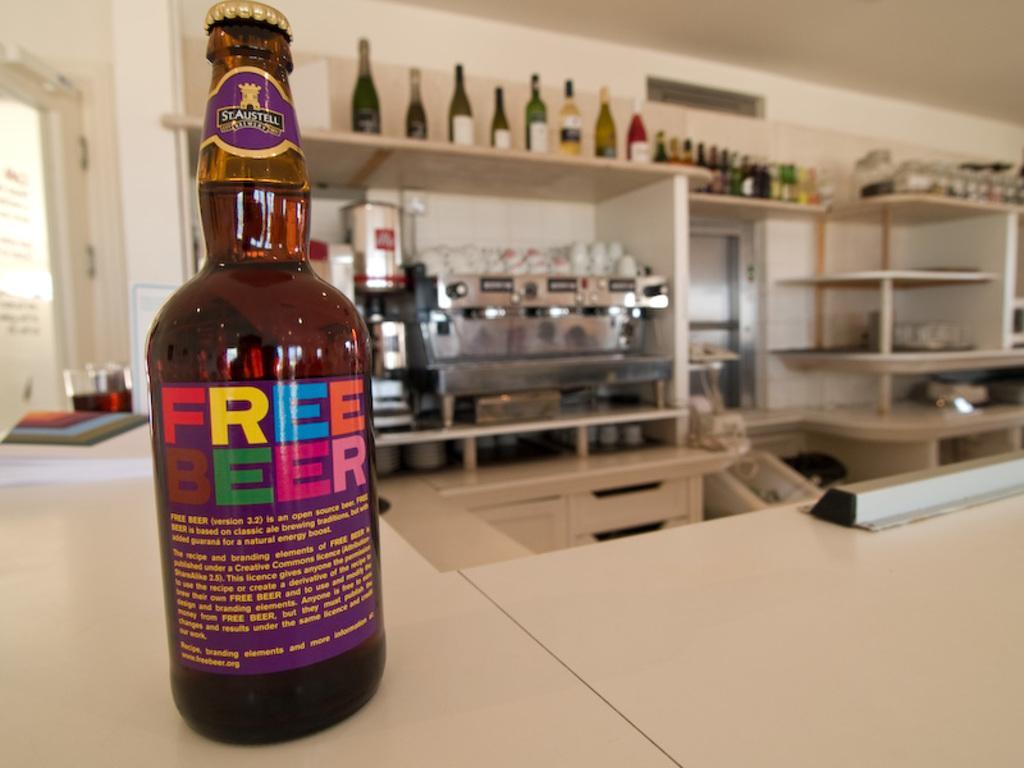How would you summarize this image in a sentence or two? This image consists of tables and there are shelves in which there are bottles. There is a bottle on the table on which "free beer" is written on it. It is in brown color. There is some liquid in it. 